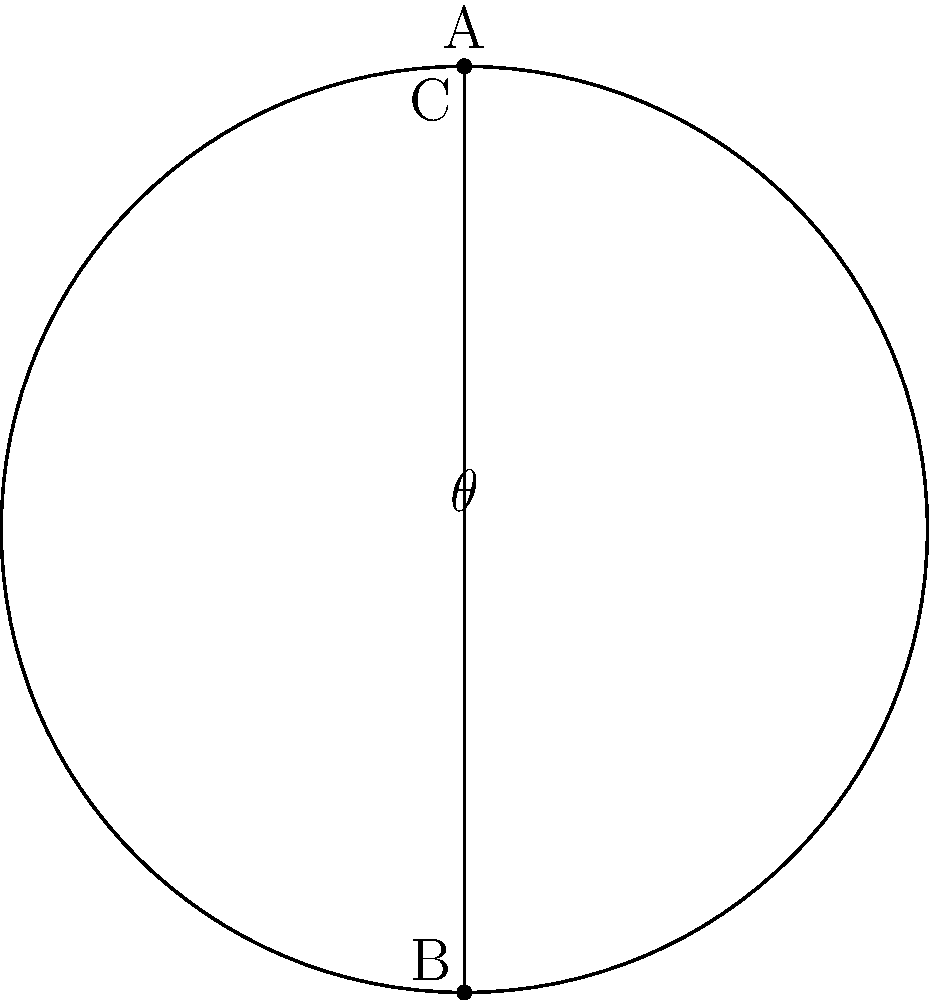In a hyperbolic geometry model represented by the Poincaré disk, a triangle ABC is inscribed in a circle as shown. If the sum of the interior angles of this triangle is less than 180°, what does this imply about the curvature of the space in this model, and how might this relate to our understanding of spacetime in general relativity? To understand this question, let's break it down step-by-step:

1. In Euclidean geometry, the sum of interior angles of a triangle is always 180°.

2. In hyperbolic geometry, represented here by the Poincaré disk model, the sum of interior angles of a triangle is always less than 180°.

3. This property is a direct result of the negative curvature of hyperbolic space. The "defect" (how much less than 180° the sum is) is proportional to the area of the triangle.

4. Negative curvature in this context means that parallel lines diverge and the space expands exponentially.

5. In general relativity, the curvature of spacetime is determined by the distribution of matter and energy. Regions with negative curvature can exist in the universe.

6. For example, in cosmology, a universe with negative curvature would be "open" and expand forever, similar to how lines diverge in hyperbolic geometry.

7. This model provides a way to visualize and study properties of negatively curved spaces, which can be applied to understanding certain aspects of spacetime in general relativity.

8. The political implications for scientific research in this area might include funding decisions for cosmology projects or particle accelerators that could help determine the overall curvature of our universe.
Answer: Negative curvature, implying an expanding space similar to certain models in general relativity. 